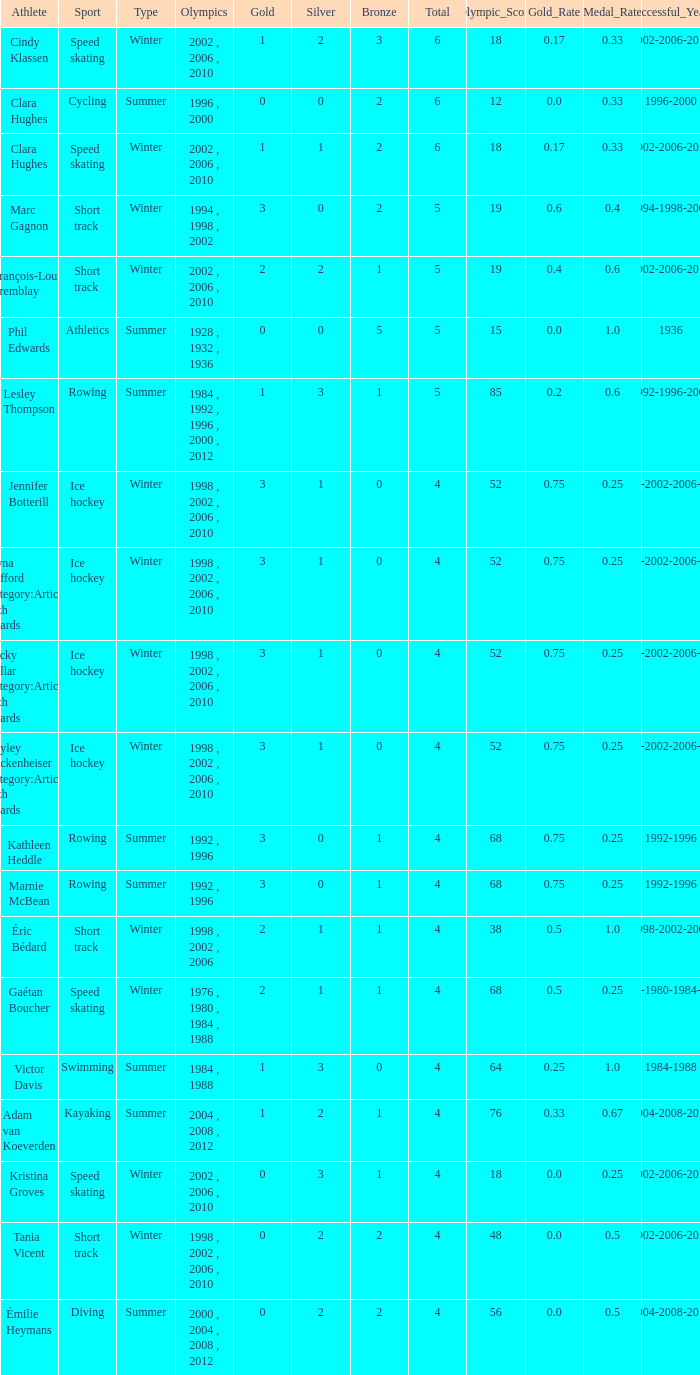What is the average gold of the winter athlete with 1 bronze, less than 3 silver, and less than 4 total medals? None. 